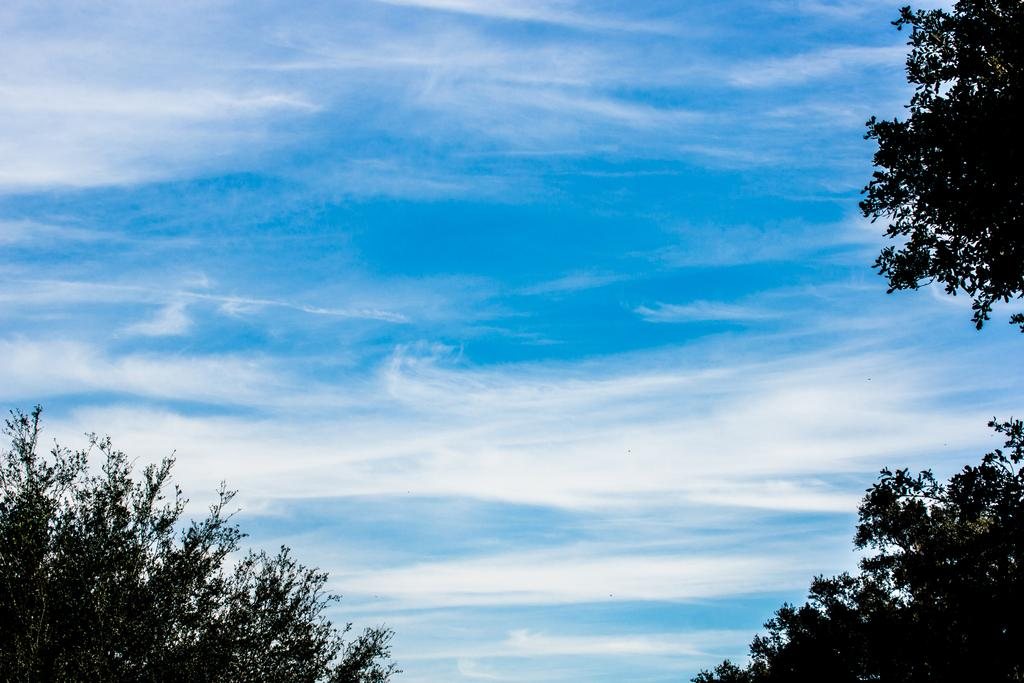What type of vegetation can be seen on both sides of the image? There are trees on either side of the image. What is visible above the trees in the image? The sky is visible in the image. What can be seen in the sky in the image? Clouds are present in the sky. How many accounts are visible in the image? There are no accounts present in the image; it features trees and a sky with clouds. Is there any quicksand visible in the image? There is no quicksand present in the image; it features trees and a sky with clouds. 